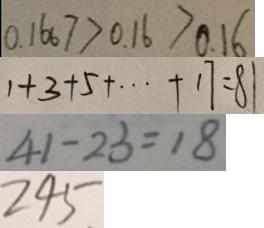Convert formula to latex. <formula><loc_0><loc_0><loc_500><loc_500>0 . 1 6 6 7 > 0 . 1 6 > 0 . 1 6 
 1 + 3 + 5 + \cdots + 1 7 = 8 1 
 4 1 - 2 3 = 1 8 
 2 4 5</formula> 